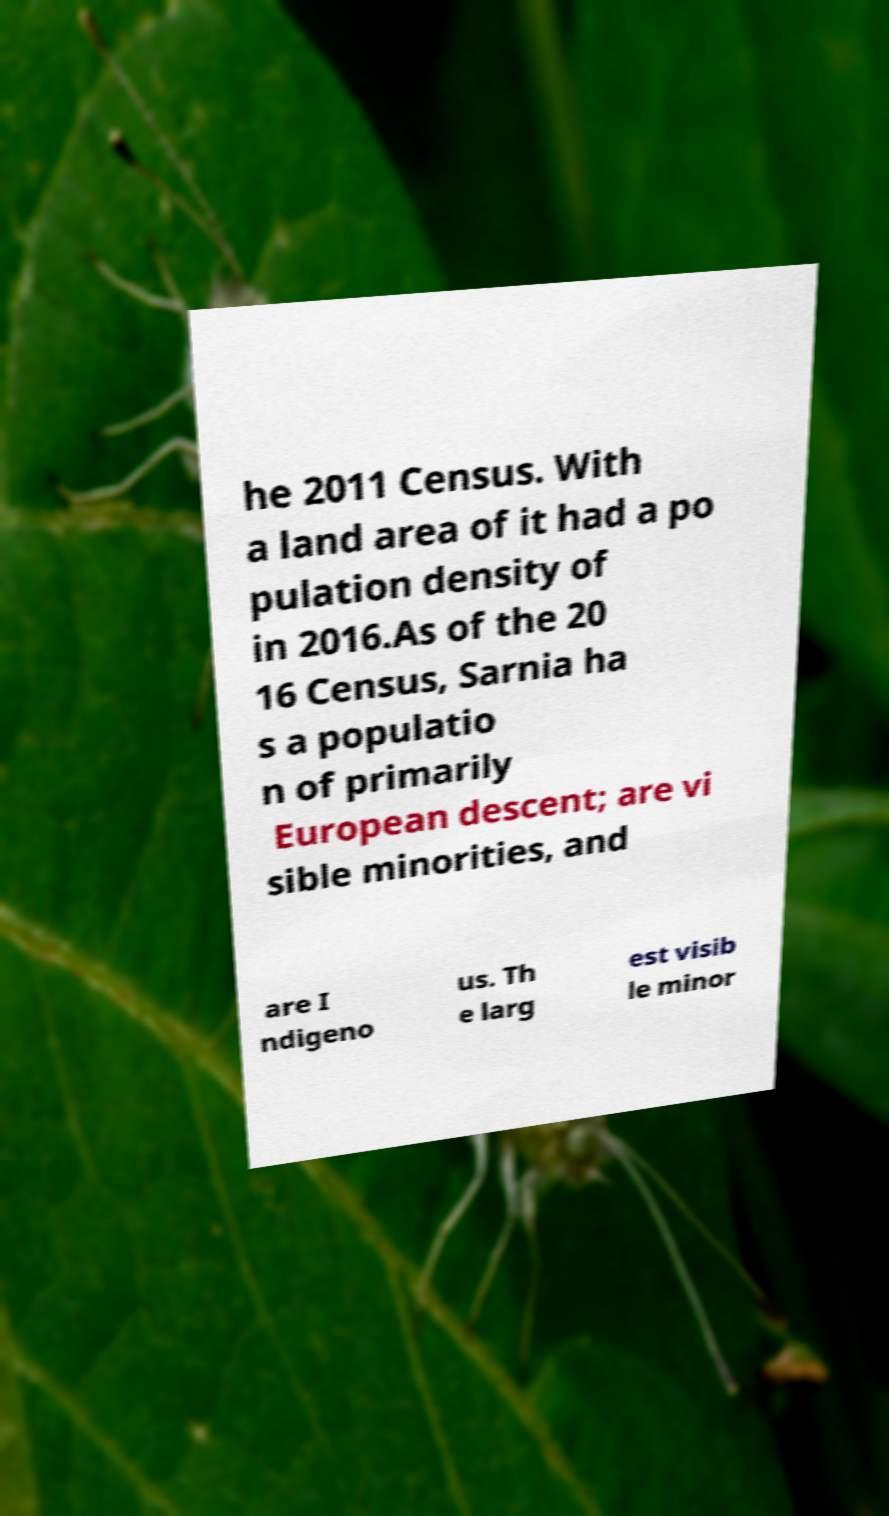Can you read and provide the text displayed in the image?This photo seems to have some interesting text. Can you extract and type it out for me? he 2011 Census. With a land area of it had a po pulation density of in 2016.As of the 20 16 Census, Sarnia ha s a populatio n of primarily European descent; are vi sible minorities, and are I ndigeno us. Th e larg est visib le minor 